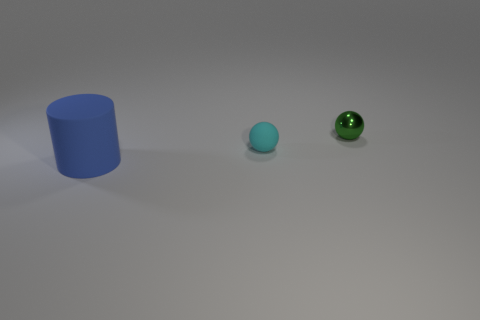Are there any cyan balls that have the same material as the cyan object?
Your response must be concise. No. Is the number of small rubber balls in front of the cyan matte thing less than the number of cyan objects?
Offer a very short reply. Yes. Is the size of the rubber object that is right of the blue cylinder the same as the blue matte cylinder?
Ensure brevity in your answer.  No. What number of big blue things have the same shape as the tiny green thing?
Your answer should be very brief. 0. There is another object that is the same material as the cyan object; what size is it?
Give a very brief answer. Large. Are there an equal number of rubber things in front of the big matte object and blue rubber cylinders?
Your answer should be very brief. No. Is the rubber ball the same color as the big rubber cylinder?
Offer a terse response. No. There is a tiny thing in front of the green metallic object; is its shape the same as the small object to the right of the tiny cyan rubber thing?
Ensure brevity in your answer.  Yes. There is a small green thing that is the same shape as the small cyan thing; what is its material?
Ensure brevity in your answer.  Metal. What is the color of the thing that is both in front of the metal sphere and behind the blue cylinder?
Give a very brief answer. Cyan. 